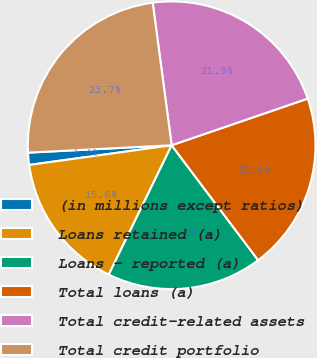Convert chart to OTSL. <chart><loc_0><loc_0><loc_500><loc_500><pie_chart><fcel>(in millions except ratios)<fcel>Loans retained (a)<fcel>Loans - reported (a)<fcel>Total loans (a)<fcel>Total credit-related assets<fcel>Total credit portfolio<nl><fcel>1.37%<fcel>15.61%<fcel>17.47%<fcel>19.99%<fcel>21.85%<fcel>23.71%<nl></chart> 